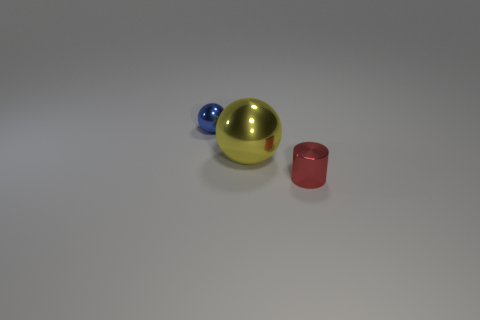Add 3 tiny blue shiny things. How many objects exist? 6 Subtract all balls. How many objects are left? 1 Subtract 1 blue balls. How many objects are left? 2 Subtract all large cyan balls. Subtract all metal cylinders. How many objects are left? 2 Add 1 big spheres. How many big spheres are left? 2 Add 1 rubber cubes. How many rubber cubes exist? 1 